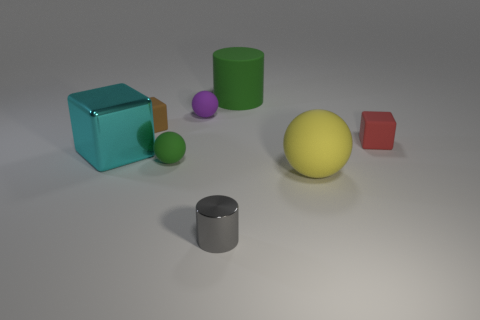Add 1 red metallic cubes. How many objects exist? 9 Subtract all red cubes. How many cubes are left? 2 Subtract 2 cylinders. How many cylinders are left? 0 Subtract all gray cylinders. How many cylinders are left? 1 Subtract all cyan cylinders. Subtract all green balls. How many cylinders are left? 2 Subtract all yellow cylinders. How many brown balls are left? 0 Subtract all green rubber cylinders. Subtract all green matte cylinders. How many objects are left? 6 Add 4 green things. How many green things are left? 6 Add 6 gray shiny things. How many gray shiny things exist? 7 Subtract 1 green cylinders. How many objects are left? 7 